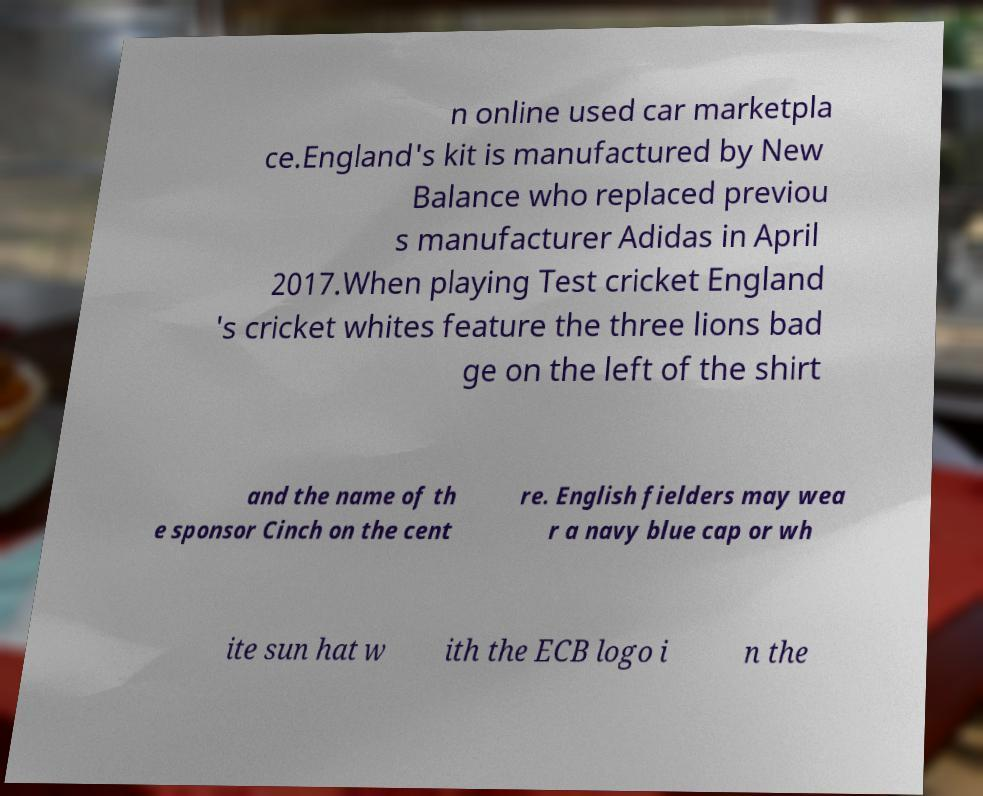Could you assist in decoding the text presented in this image and type it out clearly? n online used car marketpla ce.England's kit is manufactured by New Balance who replaced previou s manufacturer Adidas in April 2017.When playing Test cricket England 's cricket whites feature the three lions bad ge on the left of the shirt and the name of th e sponsor Cinch on the cent re. English fielders may wea r a navy blue cap or wh ite sun hat w ith the ECB logo i n the 